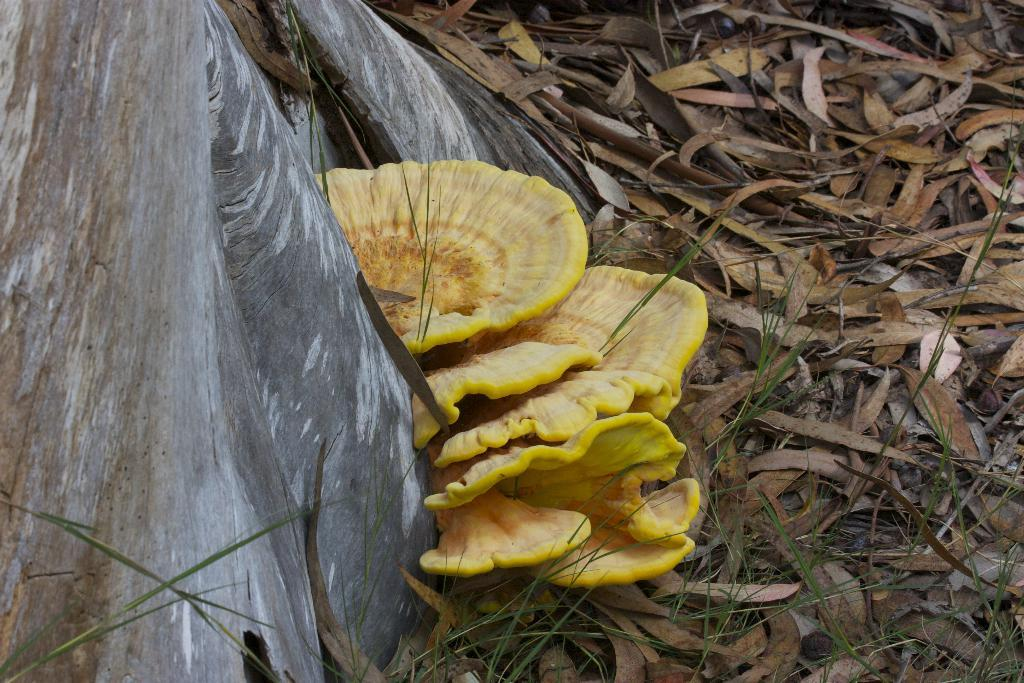What type of fungi can be seen in the image? There are mushrooms in the image. What type of plant material is present in the image? There are dried leaves in the image. What part of a tree is visible in the image? There is a tree trunk in the image. What type of milk is being poured over the mushrooms in the image? There is no milk present in the image; it features mushrooms, dried leaves, and a tree trunk. Can you see a grandmother kissing the mushrooms in the image? There is no grandmother or kissing activity present in the image. 